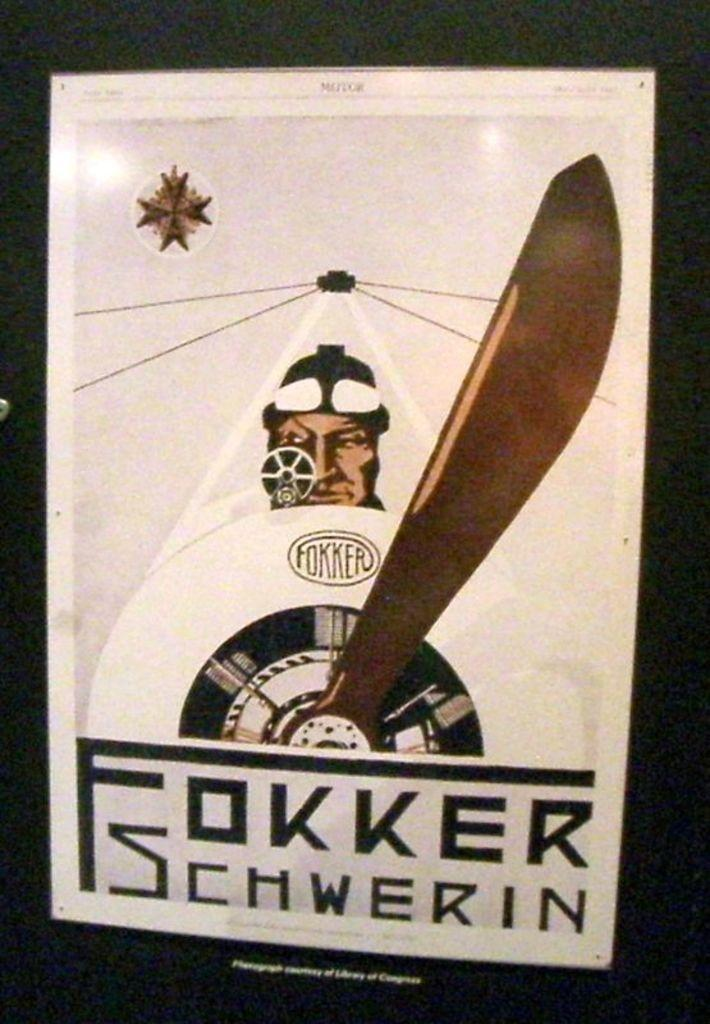What type of visual representation is shown in the image? The image is a poster. Who or what is featured in the poster? There is a person depicted in the poster. What object can be seen in the poster besides the person? There is a wheel and a hand on a clock in the poster. Where is the volcano located in the image? There is no volcano present in the image. What part of the person's body is shown in the poster? The provided facts do not specify which part of the person's body is depicted in the poster. 